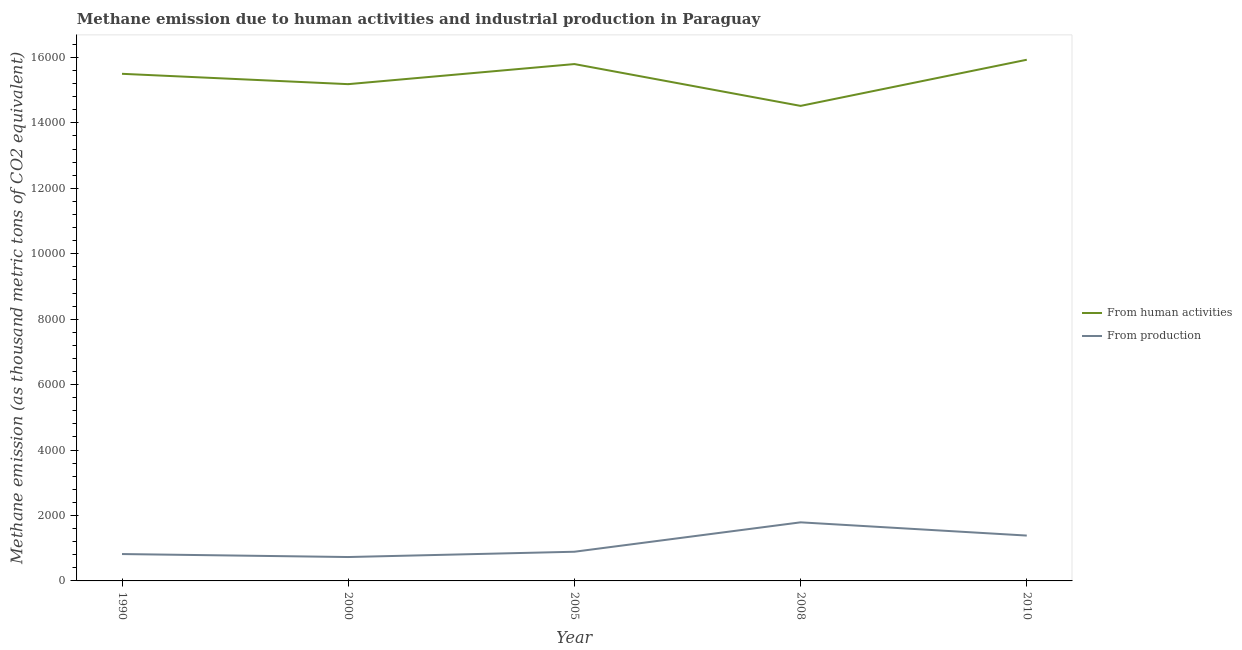How many different coloured lines are there?
Give a very brief answer. 2. Is the number of lines equal to the number of legend labels?
Your answer should be compact. Yes. What is the amount of emissions generated from industries in 2010?
Offer a terse response. 1386.2. Across all years, what is the maximum amount of emissions from human activities?
Ensure brevity in your answer.  1.59e+04. Across all years, what is the minimum amount of emissions generated from industries?
Give a very brief answer. 730.2. In which year was the amount of emissions generated from industries minimum?
Your answer should be very brief. 2000. What is the total amount of emissions from human activities in the graph?
Keep it short and to the point. 7.69e+04. What is the difference between the amount of emissions from human activities in 1990 and that in 2008?
Your answer should be compact. 980.8. What is the difference between the amount of emissions from human activities in 2008 and the amount of emissions generated from industries in 1990?
Make the answer very short. 1.37e+04. What is the average amount of emissions generated from industries per year?
Your response must be concise. 1124.12. In the year 1990, what is the difference between the amount of emissions from human activities and amount of emissions generated from industries?
Offer a very short reply. 1.47e+04. In how many years, is the amount of emissions generated from industries greater than 10000 thousand metric tons?
Your answer should be compact. 0. What is the ratio of the amount of emissions generated from industries in 2008 to that in 2010?
Make the answer very short. 1.29. Is the amount of emissions generated from industries in 1990 less than that in 2008?
Provide a short and direct response. Yes. What is the difference between the highest and the second highest amount of emissions from human activities?
Your answer should be very brief. 132.3. What is the difference between the highest and the lowest amount of emissions generated from industries?
Provide a succinct answer. 1060.5. Is the amount of emissions from human activities strictly greater than the amount of emissions generated from industries over the years?
Your answer should be very brief. Yes. Is the amount of emissions generated from industries strictly less than the amount of emissions from human activities over the years?
Keep it short and to the point. Yes. How many lines are there?
Offer a terse response. 2. How many years are there in the graph?
Offer a very short reply. 5. Are the values on the major ticks of Y-axis written in scientific E-notation?
Ensure brevity in your answer.  No. Does the graph contain grids?
Provide a short and direct response. No. How many legend labels are there?
Ensure brevity in your answer.  2. What is the title of the graph?
Your response must be concise. Methane emission due to human activities and industrial production in Paraguay. What is the label or title of the X-axis?
Your answer should be compact. Year. What is the label or title of the Y-axis?
Offer a very short reply. Methane emission (as thousand metric tons of CO2 equivalent). What is the Methane emission (as thousand metric tons of CO2 equivalent) of From human activities in 1990?
Make the answer very short. 1.55e+04. What is the Methane emission (as thousand metric tons of CO2 equivalent) of From production in 1990?
Keep it short and to the point. 821.6. What is the Methane emission (as thousand metric tons of CO2 equivalent) in From human activities in 2000?
Offer a very short reply. 1.52e+04. What is the Methane emission (as thousand metric tons of CO2 equivalent) in From production in 2000?
Offer a very short reply. 730.2. What is the Methane emission (as thousand metric tons of CO2 equivalent) of From human activities in 2005?
Ensure brevity in your answer.  1.58e+04. What is the Methane emission (as thousand metric tons of CO2 equivalent) of From production in 2005?
Offer a very short reply. 891.9. What is the Methane emission (as thousand metric tons of CO2 equivalent) in From human activities in 2008?
Provide a succinct answer. 1.45e+04. What is the Methane emission (as thousand metric tons of CO2 equivalent) of From production in 2008?
Keep it short and to the point. 1790.7. What is the Methane emission (as thousand metric tons of CO2 equivalent) of From human activities in 2010?
Your answer should be very brief. 1.59e+04. What is the Methane emission (as thousand metric tons of CO2 equivalent) in From production in 2010?
Offer a terse response. 1386.2. Across all years, what is the maximum Methane emission (as thousand metric tons of CO2 equivalent) of From human activities?
Your response must be concise. 1.59e+04. Across all years, what is the maximum Methane emission (as thousand metric tons of CO2 equivalent) of From production?
Your answer should be very brief. 1790.7. Across all years, what is the minimum Methane emission (as thousand metric tons of CO2 equivalent) of From human activities?
Ensure brevity in your answer.  1.45e+04. Across all years, what is the minimum Methane emission (as thousand metric tons of CO2 equivalent) in From production?
Ensure brevity in your answer.  730.2. What is the total Methane emission (as thousand metric tons of CO2 equivalent) of From human activities in the graph?
Keep it short and to the point. 7.69e+04. What is the total Methane emission (as thousand metric tons of CO2 equivalent) of From production in the graph?
Keep it short and to the point. 5620.6. What is the difference between the Methane emission (as thousand metric tons of CO2 equivalent) in From human activities in 1990 and that in 2000?
Offer a terse response. 316.5. What is the difference between the Methane emission (as thousand metric tons of CO2 equivalent) in From production in 1990 and that in 2000?
Make the answer very short. 91.4. What is the difference between the Methane emission (as thousand metric tons of CO2 equivalent) in From human activities in 1990 and that in 2005?
Provide a short and direct response. -297.6. What is the difference between the Methane emission (as thousand metric tons of CO2 equivalent) in From production in 1990 and that in 2005?
Offer a terse response. -70.3. What is the difference between the Methane emission (as thousand metric tons of CO2 equivalent) of From human activities in 1990 and that in 2008?
Make the answer very short. 980.8. What is the difference between the Methane emission (as thousand metric tons of CO2 equivalent) in From production in 1990 and that in 2008?
Offer a terse response. -969.1. What is the difference between the Methane emission (as thousand metric tons of CO2 equivalent) of From human activities in 1990 and that in 2010?
Your answer should be very brief. -429.9. What is the difference between the Methane emission (as thousand metric tons of CO2 equivalent) of From production in 1990 and that in 2010?
Give a very brief answer. -564.6. What is the difference between the Methane emission (as thousand metric tons of CO2 equivalent) in From human activities in 2000 and that in 2005?
Give a very brief answer. -614.1. What is the difference between the Methane emission (as thousand metric tons of CO2 equivalent) of From production in 2000 and that in 2005?
Your answer should be compact. -161.7. What is the difference between the Methane emission (as thousand metric tons of CO2 equivalent) in From human activities in 2000 and that in 2008?
Offer a very short reply. 664.3. What is the difference between the Methane emission (as thousand metric tons of CO2 equivalent) of From production in 2000 and that in 2008?
Ensure brevity in your answer.  -1060.5. What is the difference between the Methane emission (as thousand metric tons of CO2 equivalent) in From human activities in 2000 and that in 2010?
Provide a succinct answer. -746.4. What is the difference between the Methane emission (as thousand metric tons of CO2 equivalent) in From production in 2000 and that in 2010?
Provide a succinct answer. -656. What is the difference between the Methane emission (as thousand metric tons of CO2 equivalent) of From human activities in 2005 and that in 2008?
Provide a short and direct response. 1278.4. What is the difference between the Methane emission (as thousand metric tons of CO2 equivalent) of From production in 2005 and that in 2008?
Ensure brevity in your answer.  -898.8. What is the difference between the Methane emission (as thousand metric tons of CO2 equivalent) in From human activities in 2005 and that in 2010?
Make the answer very short. -132.3. What is the difference between the Methane emission (as thousand metric tons of CO2 equivalent) of From production in 2005 and that in 2010?
Give a very brief answer. -494.3. What is the difference between the Methane emission (as thousand metric tons of CO2 equivalent) of From human activities in 2008 and that in 2010?
Your response must be concise. -1410.7. What is the difference between the Methane emission (as thousand metric tons of CO2 equivalent) of From production in 2008 and that in 2010?
Keep it short and to the point. 404.5. What is the difference between the Methane emission (as thousand metric tons of CO2 equivalent) of From human activities in 1990 and the Methane emission (as thousand metric tons of CO2 equivalent) of From production in 2000?
Make the answer very short. 1.48e+04. What is the difference between the Methane emission (as thousand metric tons of CO2 equivalent) in From human activities in 1990 and the Methane emission (as thousand metric tons of CO2 equivalent) in From production in 2005?
Your answer should be very brief. 1.46e+04. What is the difference between the Methane emission (as thousand metric tons of CO2 equivalent) of From human activities in 1990 and the Methane emission (as thousand metric tons of CO2 equivalent) of From production in 2008?
Your response must be concise. 1.37e+04. What is the difference between the Methane emission (as thousand metric tons of CO2 equivalent) in From human activities in 1990 and the Methane emission (as thousand metric tons of CO2 equivalent) in From production in 2010?
Make the answer very short. 1.41e+04. What is the difference between the Methane emission (as thousand metric tons of CO2 equivalent) of From human activities in 2000 and the Methane emission (as thousand metric tons of CO2 equivalent) of From production in 2005?
Provide a short and direct response. 1.43e+04. What is the difference between the Methane emission (as thousand metric tons of CO2 equivalent) of From human activities in 2000 and the Methane emission (as thousand metric tons of CO2 equivalent) of From production in 2008?
Provide a short and direct response. 1.34e+04. What is the difference between the Methane emission (as thousand metric tons of CO2 equivalent) in From human activities in 2000 and the Methane emission (as thousand metric tons of CO2 equivalent) in From production in 2010?
Offer a very short reply. 1.38e+04. What is the difference between the Methane emission (as thousand metric tons of CO2 equivalent) in From human activities in 2005 and the Methane emission (as thousand metric tons of CO2 equivalent) in From production in 2008?
Your answer should be compact. 1.40e+04. What is the difference between the Methane emission (as thousand metric tons of CO2 equivalent) in From human activities in 2005 and the Methane emission (as thousand metric tons of CO2 equivalent) in From production in 2010?
Offer a terse response. 1.44e+04. What is the difference between the Methane emission (as thousand metric tons of CO2 equivalent) of From human activities in 2008 and the Methane emission (as thousand metric tons of CO2 equivalent) of From production in 2010?
Your answer should be very brief. 1.31e+04. What is the average Methane emission (as thousand metric tons of CO2 equivalent) of From human activities per year?
Ensure brevity in your answer.  1.54e+04. What is the average Methane emission (as thousand metric tons of CO2 equivalent) in From production per year?
Give a very brief answer. 1124.12. In the year 1990, what is the difference between the Methane emission (as thousand metric tons of CO2 equivalent) in From human activities and Methane emission (as thousand metric tons of CO2 equivalent) in From production?
Offer a terse response. 1.47e+04. In the year 2000, what is the difference between the Methane emission (as thousand metric tons of CO2 equivalent) in From human activities and Methane emission (as thousand metric tons of CO2 equivalent) in From production?
Offer a very short reply. 1.45e+04. In the year 2005, what is the difference between the Methane emission (as thousand metric tons of CO2 equivalent) in From human activities and Methane emission (as thousand metric tons of CO2 equivalent) in From production?
Offer a very short reply. 1.49e+04. In the year 2008, what is the difference between the Methane emission (as thousand metric tons of CO2 equivalent) in From human activities and Methane emission (as thousand metric tons of CO2 equivalent) in From production?
Ensure brevity in your answer.  1.27e+04. In the year 2010, what is the difference between the Methane emission (as thousand metric tons of CO2 equivalent) in From human activities and Methane emission (as thousand metric tons of CO2 equivalent) in From production?
Give a very brief answer. 1.45e+04. What is the ratio of the Methane emission (as thousand metric tons of CO2 equivalent) of From human activities in 1990 to that in 2000?
Offer a terse response. 1.02. What is the ratio of the Methane emission (as thousand metric tons of CO2 equivalent) in From production in 1990 to that in 2000?
Provide a succinct answer. 1.13. What is the ratio of the Methane emission (as thousand metric tons of CO2 equivalent) in From human activities in 1990 to that in 2005?
Keep it short and to the point. 0.98. What is the ratio of the Methane emission (as thousand metric tons of CO2 equivalent) of From production in 1990 to that in 2005?
Your answer should be very brief. 0.92. What is the ratio of the Methane emission (as thousand metric tons of CO2 equivalent) of From human activities in 1990 to that in 2008?
Provide a short and direct response. 1.07. What is the ratio of the Methane emission (as thousand metric tons of CO2 equivalent) of From production in 1990 to that in 2008?
Offer a very short reply. 0.46. What is the ratio of the Methane emission (as thousand metric tons of CO2 equivalent) in From human activities in 1990 to that in 2010?
Your response must be concise. 0.97. What is the ratio of the Methane emission (as thousand metric tons of CO2 equivalent) in From production in 1990 to that in 2010?
Offer a terse response. 0.59. What is the ratio of the Methane emission (as thousand metric tons of CO2 equivalent) in From human activities in 2000 to that in 2005?
Your response must be concise. 0.96. What is the ratio of the Methane emission (as thousand metric tons of CO2 equivalent) in From production in 2000 to that in 2005?
Offer a very short reply. 0.82. What is the ratio of the Methane emission (as thousand metric tons of CO2 equivalent) of From human activities in 2000 to that in 2008?
Your answer should be very brief. 1.05. What is the ratio of the Methane emission (as thousand metric tons of CO2 equivalent) of From production in 2000 to that in 2008?
Keep it short and to the point. 0.41. What is the ratio of the Methane emission (as thousand metric tons of CO2 equivalent) in From human activities in 2000 to that in 2010?
Your answer should be compact. 0.95. What is the ratio of the Methane emission (as thousand metric tons of CO2 equivalent) in From production in 2000 to that in 2010?
Offer a very short reply. 0.53. What is the ratio of the Methane emission (as thousand metric tons of CO2 equivalent) of From human activities in 2005 to that in 2008?
Make the answer very short. 1.09. What is the ratio of the Methane emission (as thousand metric tons of CO2 equivalent) in From production in 2005 to that in 2008?
Provide a succinct answer. 0.5. What is the ratio of the Methane emission (as thousand metric tons of CO2 equivalent) in From production in 2005 to that in 2010?
Keep it short and to the point. 0.64. What is the ratio of the Methane emission (as thousand metric tons of CO2 equivalent) of From human activities in 2008 to that in 2010?
Ensure brevity in your answer.  0.91. What is the ratio of the Methane emission (as thousand metric tons of CO2 equivalent) in From production in 2008 to that in 2010?
Keep it short and to the point. 1.29. What is the difference between the highest and the second highest Methane emission (as thousand metric tons of CO2 equivalent) of From human activities?
Make the answer very short. 132.3. What is the difference between the highest and the second highest Methane emission (as thousand metric tons of CO2 equivalent) of From production?
Make the answer very short. 404.5. What is the difference between the highest and the lowest Methane emission (as thousand metric tons of CO2 equivalent) in From human activities?
Make the answer very short. 1410.7. What is the difference between the highest and the lowest Methane emission (as thousand metric tons of CO2 equivalent) of From production?
Offer a very short reply. 1060.5. 